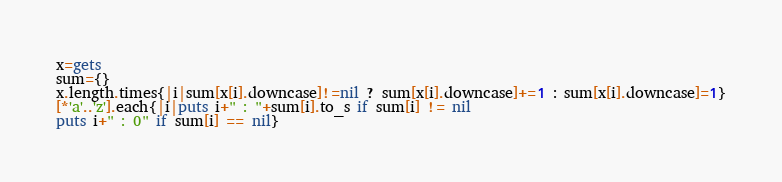<code> <loc_0><loc_0><loc_500><loc_500><_Ruby_>x=gets
sum={}
x.length.times{|i|sum[x[i].downcase]!=nil ? sum[x[i].downcase]+=1 : sum[x[i].downcase]=1}
[*'a'..'z'].each{|i|puts i+" : "+sum[i].to_s if sum[i] != nil
puts i+" : 0" if sum[i] == nil}</code> 